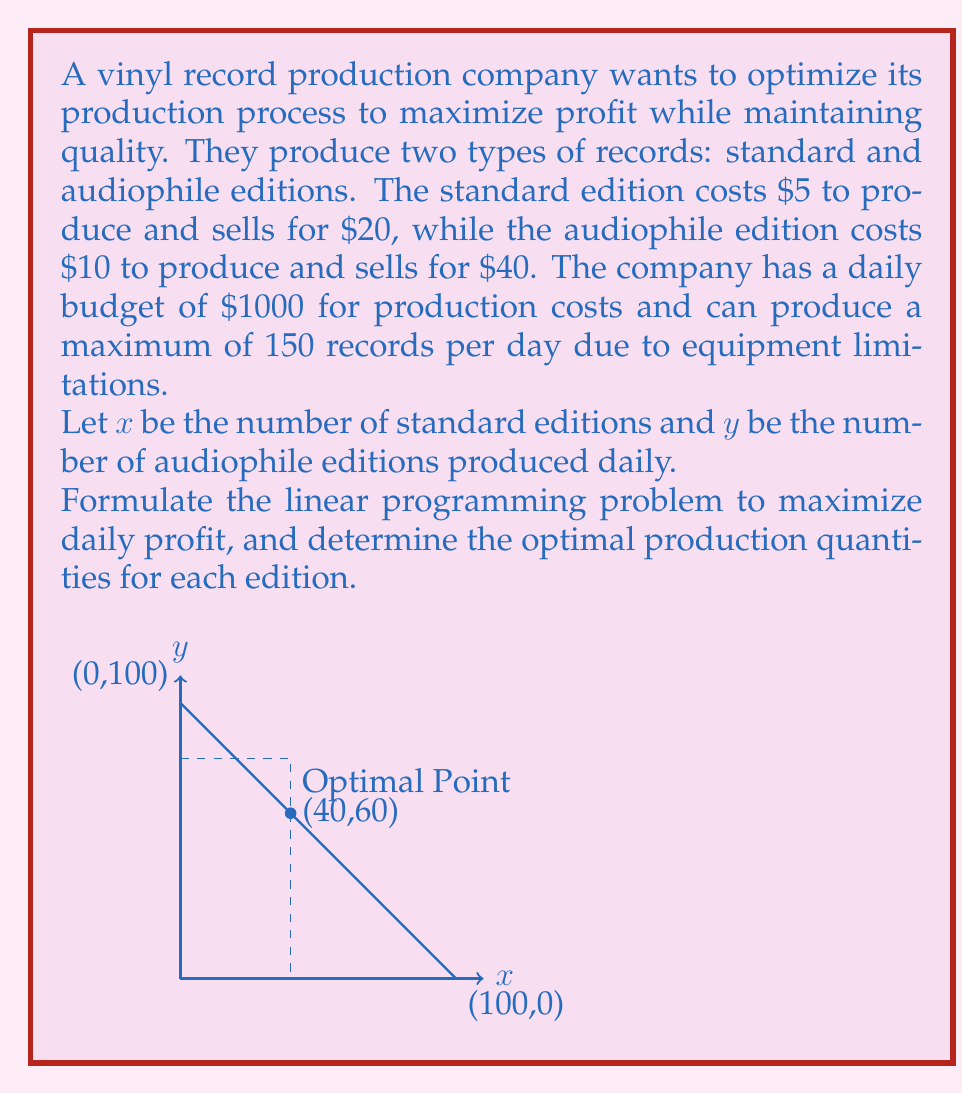Teach me how to tackle this problem. Let's approach this step-by-step:

1) First, we need to define our objective function. The profit per standard edition is $20 - $5 = $15, and for audiophile edition is $40 - $10 = $30. So our objective function is:

   Maximize $Z = 15x + 30y$

2) Now, let's define our constraints:

   a) Budget constraint: $5x + 10y \leq 1000$
   b) Production capacity constraint: $x + y \leq 150$
   c) Non-negativity constraints: $x \geq 0, y \geq 0$

3) Our complete linear programming problem is:

   Maximize $Z = 15x + 30y$
   Subject to:
   $5x + 10y \leq 1000$
   $x + y \leq 150$
   $x \geq 0, y \geq 0$

4) To solve this, we can use the graphical method. The feasible region is bounded by the lines:

   $5x + 10y = 1000$
   $x + y = 150$
   $x = 0$
   $y = 0$

5) The corners of the feasible region are:
   (0,0), (0,100), (150,0), and the intersection of the two constraint lines.

6) To find the intersection point, solve:
   $5x + 10y = 1000$
   $x + y = 150$

   Multiplying the second equation by 5:
   $5x + 10y = 1000$
   $5x + 5y = 750$

   Subtracting:
   $5y = 250$
   $y = 50$

   Substituting back:
   $x + 50 = 150$
   $x = 100$

   So the intersection point is (100, 50).

7) Evaluating the objective function at each corner:
   (0,0): $Z = 0$
   (0,100): $Z = 3000$
   (150,0): $Z = 2250$
   (100,50): $Z = 3000$

8) The maximum occurs at both (0,100) and (100,50). However, (100,50) produces a mix of both editions, which is likely more desirable for a diverse market.

Therefore, the optimal solution is to produce 100 standard editions and 50 audiophile editions daily.
Answer: 100 standard editions, 50 audiophile editions 